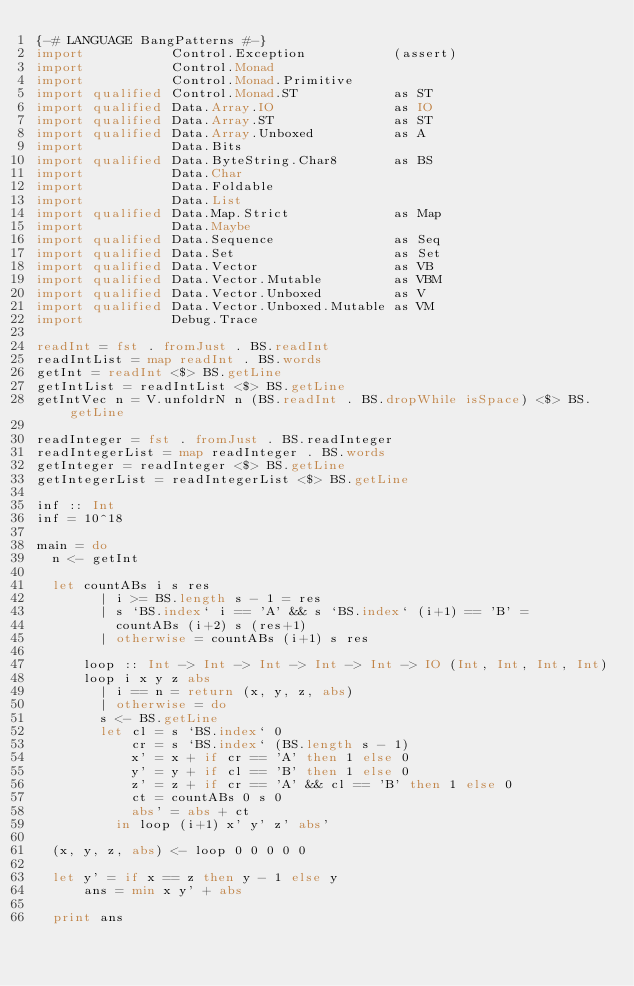Convert code to text. <code><loc_0><loc_0><loc_500><loc_500><_Haskell_>{-# LANGUAGE BangPatterns #-}
import           Control.Exception           (assert)
import           Control.Monad
import           Control.Monad.Primitive
import qualified Control.Monad.ST            as ST
import qualified Data.Array.IO               as IO
import qualified Data.Array.ST               as ST
import qualified Data.Array.Unboxed          as A
import           Data.Bits
import qualified Data.ByteString.Char8       as BS
import           Data.Char
import           Data.Foldable
import           Data.List
import qualified Data.Map.Strict             as Map
import           Data.Maybe
import qualified Data.Sequence               as Seq
import qualified Data.Set                    as Set
import qualified Data.Vector                 as VB
import qualified Data.Vector.Mutable         as VBM
import qualified Data.Vector.Unboxed         as V
import qualified Data.Vector.Unboxed.Mutable as VM
import           Debug.Trace

readInt = fst . fromJust . BS.readInt
readIntList = map readInt . BS.words
getInt = readInt <$> BS.getLine
getIntList = readIntList <$> BS.getLine
getIntVec n = V.unfoldrN n (BS.readInt . BS.dropWhile isSpace) <$> BS.getLine

readInteger = fst . fromJust . BS.readInteger
readIntegerList = map readInteger . BS.words
getInteger = readInteger <$> BS.getLine
getIntegerList = readIntegerList <$> BS.getLine

inf :: Int
inf = 10^18

main = do
  n <- getInt

  let countABs i s res
        | i >= BS.length s - 1 = res
        | s `BS.index` i == 'A' && s `BS.index` (i+1) == 'B' =
          countABs (i+2) s (res+1)
        | otherwise = countABs (i+1) s res

      loop :: Int -> Int -> Int -> Int -> Int -> IO (Int, Int, Int, Int)
      loop i x y z abs
        | i == n = return (x, y, z, abs)
        | otherwise = do
        s <- BS.getLine
        let cl = s `BS.index` 0
            cr = s `BS.index` (BS.length s - 1)
            x' = x + if cr == 'A' then 1 else 0
            y' = y + if cl == 'B' then 1 else 0
            z' = z + if cr == 'A' && cl == 'B' then 1 else 0
            ct = countABs 0 s 0
            abs' = abs + ct
          in loop (i+1) x' y' z' abs'

  (x, y, z, abs) <- loop 0 0 0 0 0

  let y' = if x == z then y - 1 else y
      ans = min x y' + abs

  print ans
</code> 